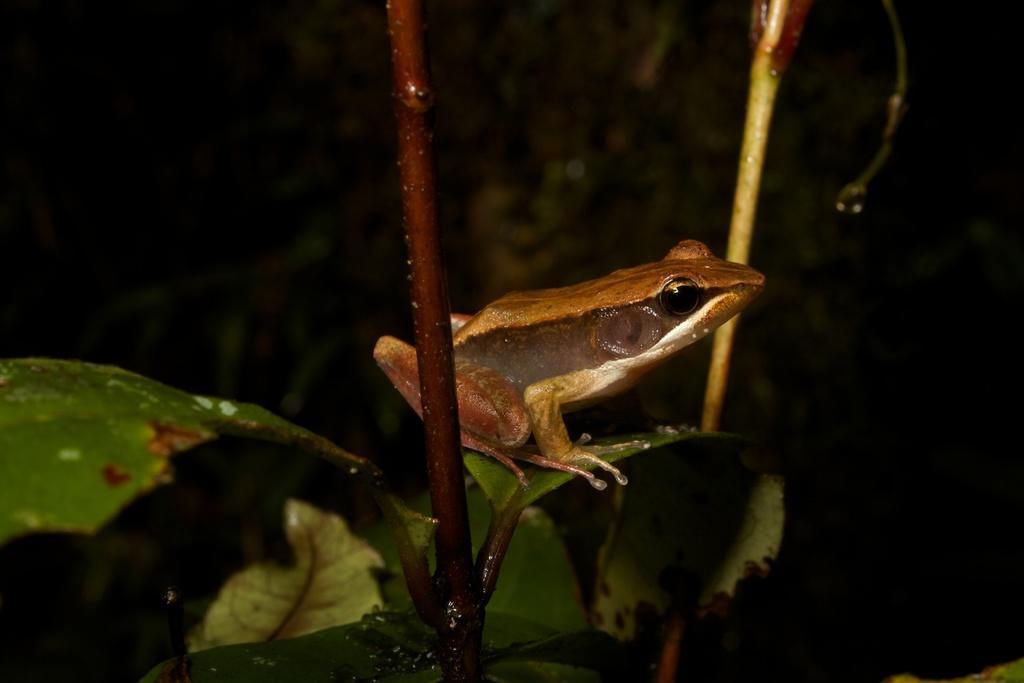Could you give a brief overview of what you see in this image? We can see frog on green leaf and we can see leaves and branches. In the background it is dark. 